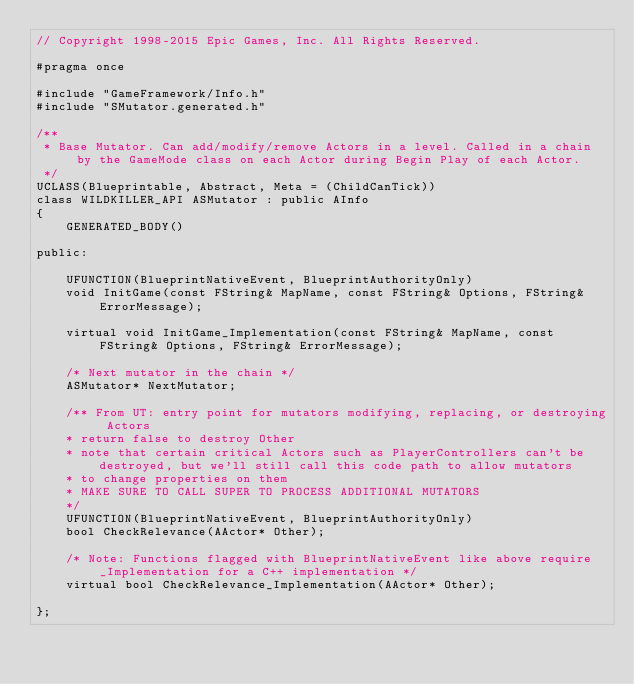<code> <loc_0><loc_0><loc_500><loc_500><_C_>// Copyright 1998-2015 Epic Games, Inc. All Rights Reserved.

#pragma once

#include "GameFramework/Info.h"
#include "SMutator.generated.h"

/**
 * Base Mutator. Can add/modify/remove Actors in a level. Called in a chain by the GameMode class on each Actor during Begin Play of each Actor.
 */
UCLASS(Blueprintable, Abstract, Meta = (ChildCanTick))
class WILDKILLER_API ASMutator : public AInfo
{
	GENERATED_BODY()

public:

	UFUNCTION(BlueprintNativeEvent, BlueprintAuthorityOnly)
	void InitGame(const FString& MapName, const FString& Options, FString& ErrorMessage);

	virtual void InitGame_Implementation(const FString& MapName, const FString& Options, FString& ErrorMessage);

	/* Next mutator in the chain */
	ASMutator* NextMutator;
	
	/** From UT: entry point for mutators modifying, replacing, or destroying Actors
	* return false to destroy Other
	* note that certain critical Actors such as PlayerControllers can't be destroyed, but we'll still call this code path to allow mutators
	* to change properties on them
	* MAKE SURE TO CALL SUPER TO PROCESS ADDITIONAL MUTATORS
	*/
	UFUNCTION(BlueprintNativeEvent, BlueprintAuthorityOnly)
	bool CheckRelevance(AActor* Other);

	/* Note: Functions flagged with BlueprintNativeEvent like above require _Implementation for a C++ implementation */
	virtual bool CheckRelevance_Implementation(AActor* Other);
	
};
</code> 